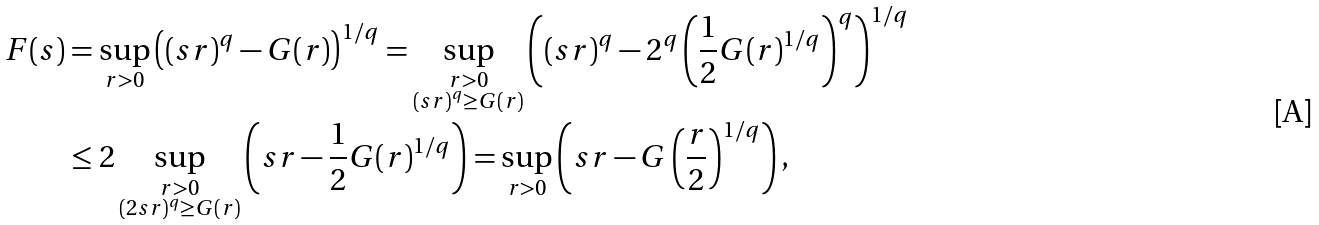<formula> <loc_0><loc_0><loc_500><loc_500>F ( s ) & = \sup _ { r > 0 } \left ( ( s r ) ^ { q } - G ( r ) \right ) ^ { 1 / q } = \sup _ { \substack { r > 0 \\ ( s r ) ^ { q } \geq G ( r ) } } \left ( ( s r ) ^ { q } - 2 ^ { q } \left ( \frac { 1 } { 2 } G ( r ) ^ { 1 / q } \right ) ^ { q } \right ) ^ { 1 / q } \\ & \leq 2 \sup _ { \substack { r > 0 \\ ( 2 s r ) ^ { q } \geq G ( r ) } } \left ( s r - \frac { 1 } { 2 } G ( r ) ^ { 1 / q } \right ) = \sup _ { r > 0 } \left ( s r - G \left ( \frac { r } { 2 } \right ) ^ { 1 / q } \right ) ,</formula> 